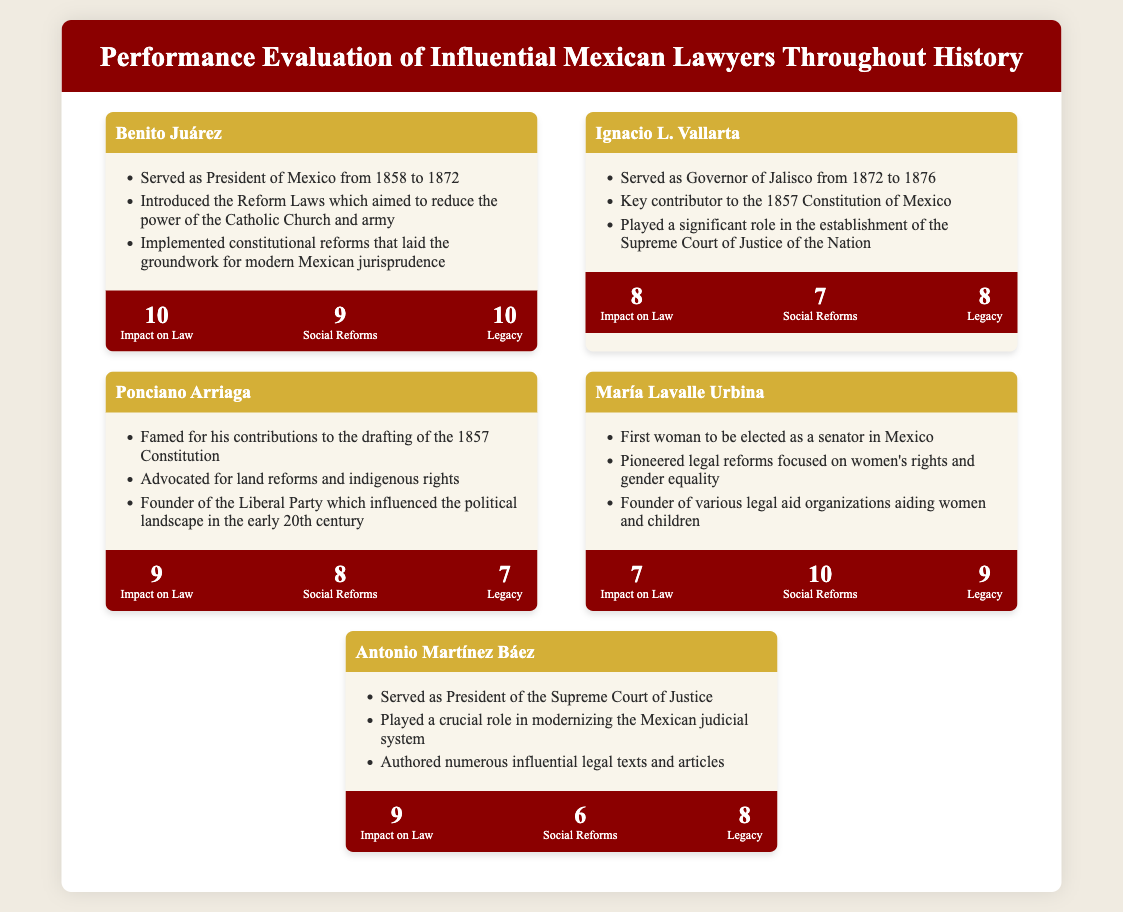What is the name of the first woman to be elected as a senator in Mexico? The document lists María Lavalle Urbina as the first woman senator, highlighting her significant achievements.
Answer: María Lavalle Urbina What was the primary legal reform introduced by Benito Juárez? The document mentions that Benito Juárez introduced the Reform Laws aimed at reducing the power of the Catholic Church and army.
Answer: Reform Laws What score did Ignacio L. Vallarta receive for Social Reforms? The evaluation section provides Ignacio L. Vallarta's score for Social Reforms, which is a numerical indicator of his impact in this area.
Answer: 7 Which lawyer is noted for advocating land reforms and indigenous rights? The document specifies that Ponciano Arriaga is recognized for these particular contributions.
Answer: Ponciano Arriaga What achievement is associated with Antonio Martínez Báez? The document notes Antonio Martínez Báez served as President of the Supreme Court of Justice.
Answer: President of the Supreme Court of Justice Which influential lawyer has the highest evaluation score for Legacy? The evaluations show that Benito Juárez has the highest score for Legacy, indicating his lasting impact.
Answer: 10 Which two lawyers are noted for their contributions to the establishment of the Supreme Court? The document indicates that Ignacio L. Vallarta and Antonio Martínez Báez contributed significantly to this establishment.
Answer: Ignacio L. Vallarta and Antonio Martínez Báez What does María Lavalle Urbina's score indicate about her impact on law? The evaluation score for Impact on Law is a direct measure of her contributions based on the document.
Answer: 7 What key legal document did Ponciano Arriaga contribute to? The document directly states that Ponciano Arriaga was famous for his contributions to the drafting of the 1857 Constitution.
Answer: 1857 Constitution 